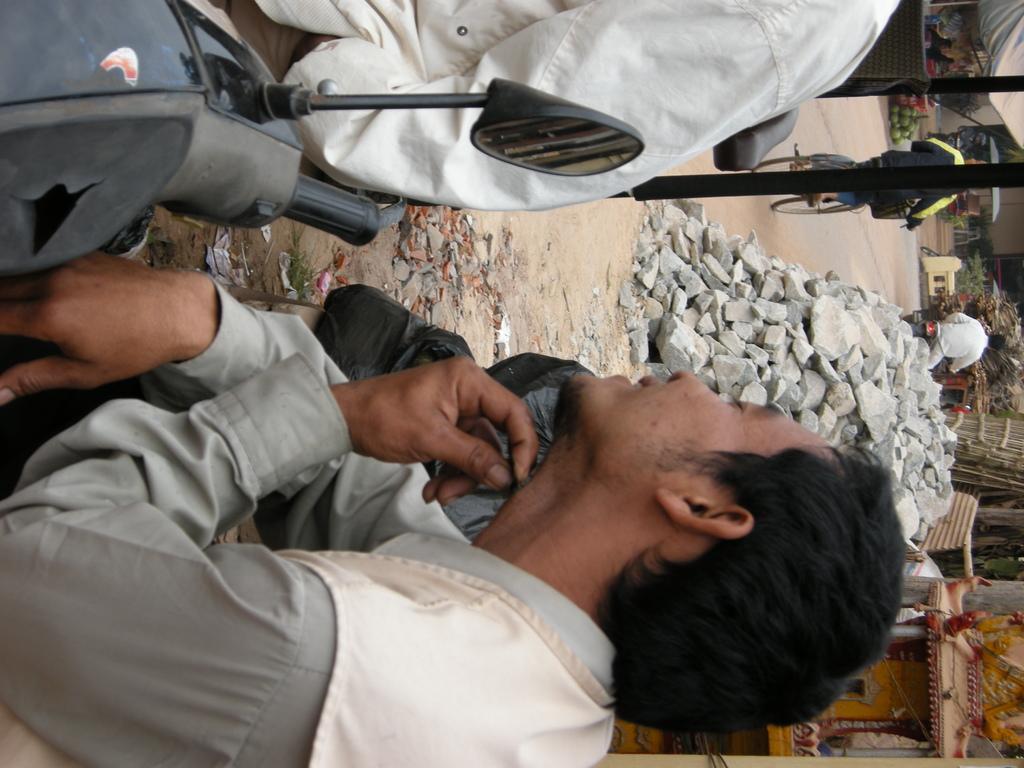Could you give a brief overview of what you see in this image? This image consists of a man sitting on a bike. In the background, there are rocks. At the bottom, there is a road. In the middle, there is a man riding bicycle. 